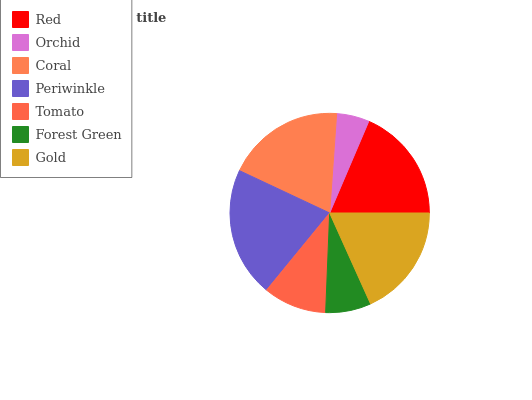Is Orchid the minimum?
Answer yes or no. Yes. Is Periwinkle the maximum?
Answer yes or no. Yes. Is Coral the minimum?
Answer yes or no. No. Is Coral the maximum?
Answer yes or no. No. Is Coral greater than Orchid?
Answer yes or no. Yes. Is Orchid less than Coral?
Answer yes or no. Yes. Is Orchid greater than Coral?
Answer yes or no. No. Is Coral less than Orchid?
Answer yes or no. No. Is Gold the high median?
Answer yes or no. Yes. Is Gold the low median?
Answer yes or no. Yes. Is Tomato the high median?
Answer yes or no. No. Is Coral the low median?
Answer yes or no. No. 